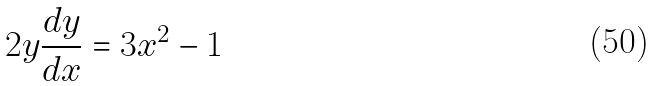Convert formula to latex. <formula><loc_0><loc_0><loc_500><loc_500>2 y \frac { d y } { d x } = 3 x ^ { 2 } - 1</formula> 